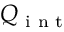<formula> <loc_0><loc_0><loc_500><loc_500>Q _ { i n t }</formula> 